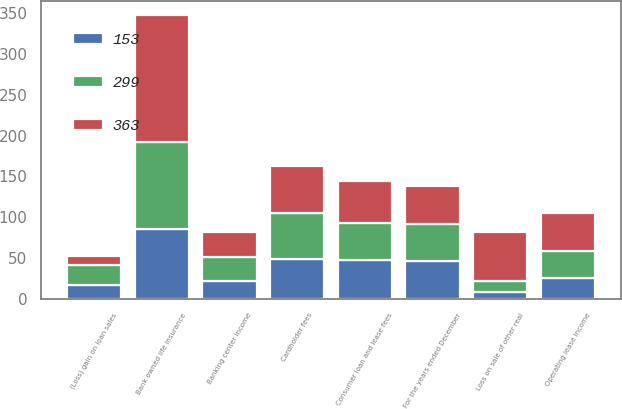<chart> <loc_0><loc_0><loc_500><loc_500><stacked_bar_chart><ecel><fcel>For the years ended December<fcel>Cardholder fees<fcel>Consumer loan and lease fees<fcel>Operating lease income<fcel>Banking center income<fcel>(Loss) gain on loan sales<fcel>Loss on sale of other real<fcel>Bank owned life insurance<nl><fcel>363<fcel>46<fcel>58<fcel>51<fcel>47<fcel>31<fcel>11<fcel>60<fcel>156<nl><fcel>299<fcel>46<fcel>56<fcel>46<fcel>32<fcel>29<fcel>25<fcel>14<fcel>106<nl><fcel>153<fcel>46<fcel>49<fcel>47<fcel>26<fcel>22<fcel>17<fcel>8<fcel>86<nl></chart> 